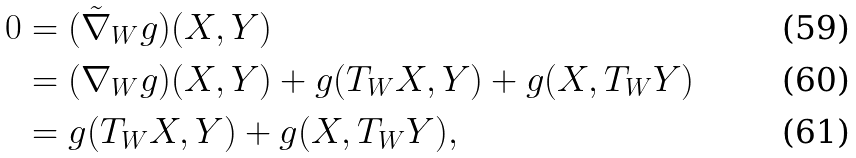<formula> <loc_0><loc_0><loc_500><loc_500>0 & = ( \tilde { \nabla } _ { W } g ) ( X , Y ) \\ & = ( \nabla _ { W } g ) ( X , Y ) + g ( T _ { W } X , Y ) + g ( X , T _ { W } Y ) \\ & = g ( T _ { W } X , Y ) + g ( X , T _ { W } Y ) ,</formula> 